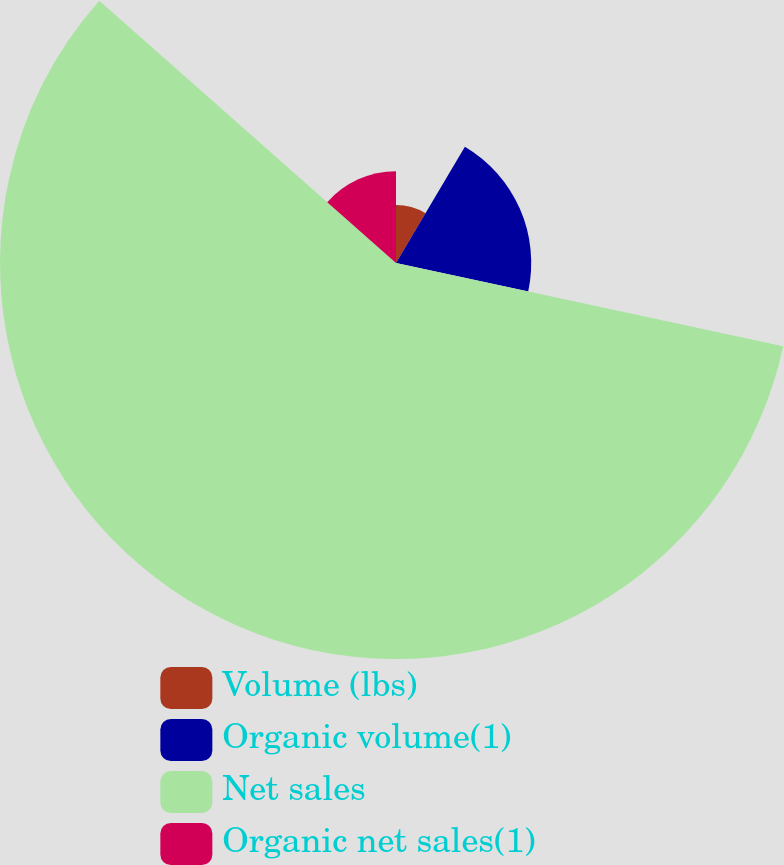Convert chart. <chart><loc_0><loc_0><loc_500><loc_500><pie_chart><fcel>Volume (lbs)<fcel>Organic volume(1)<fcel>Net sales<fcel>Organic net sales(1)<nl><fcel>8.51%<fcel>19.86%<fcel>58.16%<fcel>13.48%<nl></chart> 